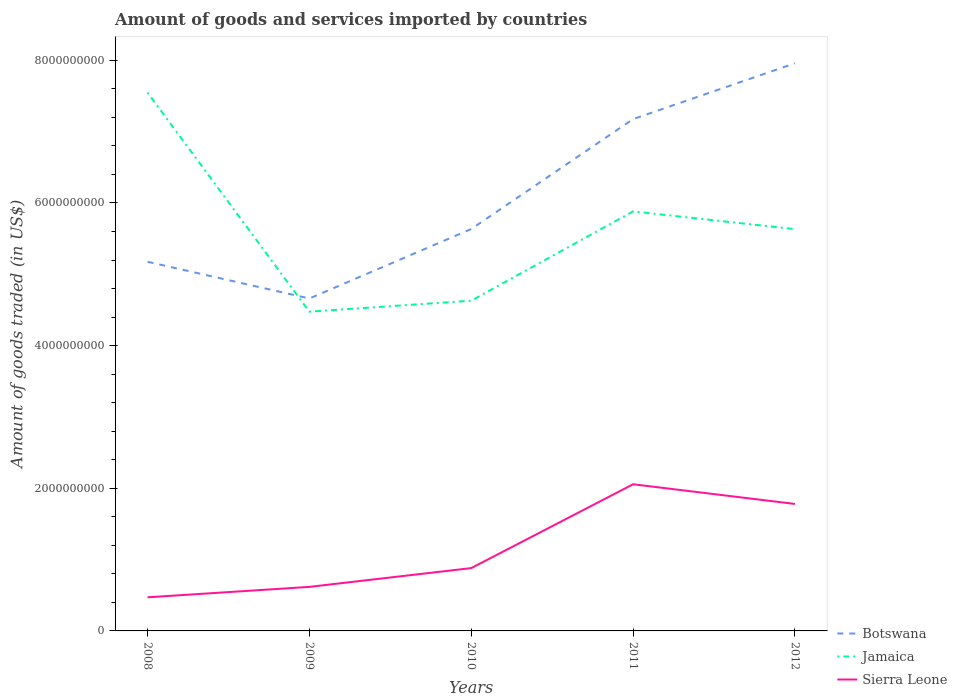How many different coloured lines are there?
Provide a short and direct response. 3. Is the number of lines equal to the number of legend labels?
Offer a terse response. Yes. Across all years, what is the maximum total amount of goods and services imported in Botswana?
Keep it short and to the point. 4.66e+09. What is the total total amount of goods and services imported in Jamaica in the graph?
Provide a succinct answer. -1.41e+09. What is the difference between the highest and the second highest total amount of goods and services imported in Jamaica?
Offer a very short reply. 3.07e+09. How many years are there in the graph?
Offer a very short reply. 5. What is the difference between two consecutive major ticks on the Y-axis?
Your answer should be compact. 2.00e+09. Are the values on the major ticks of Y-axis written in scientific E-notation?
Give a very brief answer. No. How are the legend labels stacked?
Offer a terse response. Vertical. What is the title of the graph?
Ensure brevity in your answer.  Amount of goods and services imported by countries. Does "Senegal" appear as one of the legend labels in the graph?
Provide a succinct answer. No. What is the label or title of the Y-axis?
Offer a very short reply. Amount of goods traded (in US$). What is the Amount of goods traded (in US$) in Botswana in 2008?
Ensure brevity in your answer.  5.18e+09. What is the Amount of goods traded (in US$) in Jamaica in 2008?
Provide a succinct answer. 7.55e+09. What is the Amount of goods traded (in US$) in Sierra Leone in 2008?
Provide a short and direct response. 4.71e+08. What is the Amount of goods traded (in US$) in Botswana in 2009?
Your response must be concise. 4.66e+09. What is the Amount of goods traded (in US$) in Jamaica in 2009?
Make the answer very short. 4.48e+09. What is the Amount of goods traded (in US$) in Sierra Leone in 2009?
Your answer should be compact. 6.18e+08. What is the Amount of goods traded (in US$) of Botswana in 2010?
Ensure brevity in your answer.  5.63e+09. What is the Amount of goods traded (in US$) in Jamaica in 2010?
Ensure brevity in your answer.  4.63e+09. What is the Amount of goods traded (in US$) of Sierra Leone in 2010?
Your answer should be compact. 8.81e+08. What is the Amount of goods traded (in US$) of Botswana in 2011?
Your response must be concise. 7.18e+09. What is the Amount of goods traded (in US$) of Jamaica in 2011?
Keep it short and to the point. 5.88e+09. What is the Amount of goods traded (in US$) of Sierra Leone in 2011?
Provide a succinct answer. 2.06e+09. What is the Amount of goods traded (in US$) in Botswana in 2012?
Offer a terse response. 7.96e+09. What is the Amount of goods traded (in US$) in Jamaica in 2012?
Offer a terse response. 5.63e+09. What is the Amount of goods traded (in US$) in Sierra Leone in 2012?
Keep it short and to the point. 1.78e+09. Across all years, what is the maximum Amount of goods traded (in US$) in Botswana?
Keep it short and to the point. 7.96e+09. Across all years, what is the maximum Amount of goods traded (in US$) of Jamaica?
Offer a very short reply. 7.55e+09. Across all years, what is the maximum Amount of goods traded (in US$) of Sierra Leone?
Your answer should be very brief. 2.06e+09. Across all years, what is the minimum Amount of goods traded (in US$) of Botswana?
Offer a very short reply. 4.66e+09. Across all years, what is the minimum Amount of goods traded (in US$) in Jamaica?
Ensure brevity in your answer.  4.48e+09. Across all years, what is the minimum Amount of goods traded (in US$) of Sierra Leone?
Provide a short and direct response. 4.71e+08. What is the total Amount of goods traded (in US$) in Botswana in the graph?
Your answer should be very brief. 3.06e+1. What is the total Amount of goods traded (in US$) of Jamaica in the graph?
Give a very brief answer. 2.82e+1. What is the total Amount of goods traded (in US$) of Sierra Leone in the graph?
Make the answer very short. 5.81e+09. What is the difference between the Amount of goods traded (in US$) in Botswana in 2008 and that in 2009?
Make the answer very short. 5.15e+08. What is the difference between the Amount of goods traded (in US$) in Jamaica in 2008 and that in 2009?
Your response must be concise. 3.07e+09. What is the difference between the Amount of goods traded (in US$) of Sierra Leone in 2008 and that in 2009?
Provide a short and direct response. -1.46e+08. What is the difference between the Amount of goods traded (in US$) of Botswana in 2008 and that in 2010?
Provide a short and direct response. -4.59e+08. What is the difference between the Amount of goods traded (in US$) of Jamaica in 2008 and that in 2010?
Keep it short and to the point. 2.92e+09. What is the difference between the Amount of goods traded (in US$) of Sierra Leone in 2008 and that in 2010?
Your answer should be very brief. -4.10e+08. What is the difference between the Amount of goods traded (in US$) in Botswana in 2008 and that in 2011?
Give a very brief answer. -2.00e+09. What is the difference between the Amount of goods traded (in US$) in Jamaica in 2008 and that in 2011?
Your response must be concise. 1.67e+09. What is the difference between the Amount of goods traded (in US$) in Sierra Leone in 2008 and that in 2011?
Your answer should be very brief. -1.58e+09. What is the difference between the Amount of goods traded (in US$) of Botswana in 2008 and that in 2012?
Offer a terse response. -2.78e+09. What is the difference between the Amount of goods traded (in US$) of Jamaica in 2008 and that in 2012?
Your answer should be very brief. 1.91e+09. What is the difference between the Amount of goods traded (in US$) of Sierra Leone in 2008 and that in 2012?
Make the answer very short. -1.31e+09. What is the difference between the Amount of goods traded (in US$) in Botswana in 2009 and that in 2010?
Ensure brevity in your answer.  -9.74e+08. What is the difference between the Amount of goods traded (in US$) of Jamaica in 2009 and that in 2010?
Provide a succinct answer. -1.54e+08. What is the difference between the Amount of goods traded (in US$) of Sierra Leone in 2009 and that in 2010?
Your answer should be very brief. -2.63e+08. What is the difference between the Amount of goods traded (in US$) of Botswana in 2009 and that in 2011?
Give a very brief answer. -2.52e+09. What is the difference between the Amount of goods traded (in US$) of Jamaica in 2009 and that in 2011?
Your answer should be very brief. -1.41e+09. What is the difference between the Amount of goods traded (in US$) in Sierra Leone in 2009 and that in 2011?
Your answer should be compact. -1.44e+09. What is the difference between the Amount of goods traded (in US$) of Botswana in 2009 and that in 2012?
Offer a very short reply. -3.30e+09. What is the difference between the Amount of goods traded (in US$) of Jamaica in 2009 and that in 2012?
Give a very brief answer. -1.16e+09. What is the difference between the Amount of goods traded (in US$) of Sierra Leone in 2009 and that in 2012?
Provide a succinct answer. -1.16e+09. What is the difference between the Amount of goods traded (in US$) of Botswana in 2010 and that in 2011?
Give a very brief answer. -1.54e+09. What is the difference between the Amount of goods traded (in US$) of Jamaica in 2010 and that in 2011?
Your answer should be compact. -1.25e+09. What is the difference between the Amount of goods traded (in US$) of Sierra Leone in 2010 and that in 2011?
Your answer should be compact. -1.18e+09. What is the difference between the Amount of goods traded (in US$) of Botswana in 2010 and that in 2012?
Keep it short and to the point. -2.32e+09. What is the difference between the Amount of goods traded (in US$) of Jamaica in 2010 and that in 2012?
Ensure brevity in your answer.  -1.00e+09. What is the difference between the Amount of goods traded (in US$) of Sierra Leone in 2010 and that in 2012?
Offer a terse response. -8.99e+08. What is the difference between the Amount of goods traded (in US$) of Botswana in 2011 and that in 2012?
Keep it short and to the point. -7.83e+08. What is the difference between the Amount of goods traded (in US$) of Jamaica in 2011 and that in 2012?
Provide a succinct answer. 2.49e+08. What is the difference between the Amount of goods traded (in US$) of Sierra Leone in 2011 and that in 2012?
Ensure brevity in your answer.  2.76e+08. What is the difference between the Amount of goods traded (in US$) in Botswana in 2008 and the Amount of goods traded (in US$) in Jamaica in 2009?
Make the answer very short. 7.00e+08. What is the difference between the Amount of goods traded (in US$) in Botswana in 2008 and the Amount of goods traded (in US$) in Sierra Leone in 2009?
Offer a very short reply. 4.56e+09. What is the difference between the Amount of goods traded (in US$) in Jamaica in 2008 and the Amount of goods traded (in US$) in Sierra Leone in 2009?
Offer a terse response. 6.93e+09. What is the difference between the Amount of goods traded (in US$) of Botswana in 2008 and the Amount of goods traded (in US$) of Jamaica in 2010?
Make the answer very short. 5.46e+08. What is the difference between the Amount of goods traded (in US$) in Botswana in 2008 and the Amount of goods traded (in US$) in Sierra Leone in 2010?
Offer a terse response. 4.29e+09. What is the difference between the Amount of goods traded (in US$) of Jamaica in 2008 and the Amount of goods traded (in US$) of Sierra Leone in 2010?
Provide a succinct answer. 6.67e+09. What is the difference between the Amount of goods traded (in US$) of Botswana in 2008 and the Amount of goods traded (in US$) of Jamaica in 2011?
Offer a terse response. -7.06e+08. What is the difference between the Amount of goods traded (in US$) of Botswana in 2008 and the Amount of goods traded (in US$) of Sierra Leone in 2011?
Ensure brevity in your answer.  3.12e+09. What is the difference between the Amount of goods traded (in US$) of Jamaica in 2008 and the Amount of goods traded (in US$) of Sierra Leone in 2011?
Give a very brief answer. 5.49e+09. What is the difference between the Amount of goods traded (in US$) of Botswana in 2008 and the Amount of goods traded (in US$) of Jamaica in 2012?
Your answer should be very brief. -4.57e+08. What is the difference between the Amount of goods traded (in US$) in Botswana in 2008 and the Amount of goods traded (in US$) in Sierra Leone in 2012?
Your answer should be compact. 3.40e+09. What is the difference between the Amount of goods traded (in US$) of Jamaica in 2008 and the Amount of goods traded (in US$) of Sierra Leone in 2012?
Keep it short and to the point. 5.77e+09. What is the difference between the Amount of goods traded (in US$) of Botswana in 2009 and the Amount of goods traded (in US$) of Jamaica in 2010?
Your response must be concise. 3.10e+07. What is the difference between the Amount of goods traded (in US$) in Botswana in 2009 and the Amount of goods traded (in US$) in Sierra Leone in 2010?
Provide a short and direct response. 3.78e+09. What is the difference between the Amount of goods traded (in US$) in Jamaica in 2009 and the Amount of goods traded (in US$) in Sierra Leone in 2010?
Provide a succinct answer. 3.59e+09. What is the difference between the Amount of goods traded (in US$) in Botswana in 2009 and the Amount of goods traded (in US$) in Jamaica in 2011?
Keep it short and to the point. -1.22e+09. What is the difference between the Amount of goods traded (in US$) in Botswana in 2009 and the Amount of goods traded (in US$) in Sierra Leone in 2011?
Give a very brief answer. 2.60e+09. What is the difference between the Amount of goods traded (in US$) of Jamaica in 2009 and the Amount of goods traded (in US$) of Sierra Leone in 2011?
Offer a terse response. 2.42e+09. What is the difference between the Amount of goods traded (in US$) of Botswana in 2009 and the Amount of goods traded (in US$) of Jamaica in 2012?
Your answer should be compact. -9.72e+08. What is the difference between the Amount of goods traded (in US$) of Botswana in 2009 and the Amount of goods traded (in US$) of Sierra Leone in 2012?
Your answer should be very brief. 2.88e+09. What is the difference between the Amount of goods traded (in US$) of Jamaica in 2009 and the Amount of goods traded (in US$) of Sierra Leone in 2012?
Offer a very short reply. 2.70e+09. What is the difference between the Amount of goods traded (in US$) of Botswana in 2010 and the Amount of goods traded (in US$) of Jamaica in 2011?
Offer a very short reply. -2.47e+08. What is the difference between the Amount of goods traded (in US$) in Botswana in 2010 and the Amount of goods traded (in US$) in Sierra Leone in 2011?
Give a very brief answer. 3.58e+09. What is the difference between the Amount of goods traded (in US$) of Jamaica in 2010 and the Amount of goods traded (in US$) of Sierra Leone in 2011?
Provide a short and direct response. 2.57e+09. What is the difference between the Amount of goods traded (in US$) in Botswana in 2010 and the Amount of goods traded (in US$) in Jamaica in 2012?
Ensure brevity in your answer.  1.99e+06. What is the difference between the Amount of goods traded (in US$) in Botswana in 2010 and the Amount of goods traded (in US$) in Sierra Leone in 2012?
Provide a succinct answer. 3.85e+09. What is the difference between the Amount of goods traded (in US$) of Jamaica in 2010 and the Amount of goods traded (in US$) of Sierra Leone in 2012?
Ensure brevity in your answer.  2.85e+09. What is the difference between the Amount of goods traded (in US$) in Botswana in 2011 and the Amount of goods traded (in US$) in Jamaica in 2012?
Your response must be concise. 1.54e+09. What is the difference between the Amount of goods traded (in US$) in Botswana in 2011 and the Amount of goods traded (in US$) in Sierra Leone in 2012?
Your answer should be compact. 5.40e+09. What is the difference between the Amount of goods traded (in US$) of Jamaica in 2011 and the Amount of goods traded (in US$) of Sierra Leone in 2012?
Keep it short and to the point. 4.10e+09. What is the average Amount of goods traded (in US$) of Botswana per year?
Offer a very short reply. 6.12e+09. What is the average Amount of goods traded (in US$) in Jamaica per year?
Provide a succinct answer. 5.63e+09. What is the average Amount of goods traded (in US$) in Sierra Leone per year?
Give a very brief answer. 1.16e+09. In the year 2008, what is the difference between the Amount of goods traded (in US$) in Botswana and Amount of goods traded (in US$) in Jamaica?
Ensure brevity in your answer.  -2.37e+09. In the year 2008, what is the difference between the Amount of goods traded (in US$) in Botswana and Amount of goods traded (in US$) in Sierra Leone?
Offer a very short reply. 4.70e+09. In the year 2008, what is the difference between the Amount of goods traded (in US$) of Jamaica and Amount of goods traded (in US$) of Sierra Leone?
Make the answer very short. 7.08e+09. In the year 2009, what is the difference between the Amount of goods traded (in US$) in Botswana and Amount of goods traded (in US$) in Jamaica?
Provide a short and direct response. 1.85e+08. In the year 2009, what is the difference between the Amount of goods traded (in US$) of Botswana and Amount of goods traded (in US$) of Sierra Leone?
Give a very brief answer. 4.04e+09. In the year 2009, what is the difference between the Amount of goods traded (in US$) in Jamaica and Amount of goods traded (in US$) in Sierra Leone?
Keep it short and to the point. 3.86e+09. In the year 2010, what is the difference between the Amount of goods traded (in US$) in Botswana and Amount of goods traded (in US$) in Jamaica?
Your answer should be compact. 1.00e+09. In the year 2010, what is the difference between the Amount of goods traded (in US$) in Botswana and Amount of goods traded (in US$) in Sierra Leone?
Ensure brevity in your answer.  4.75e+09. In the year 2010, what is the difference between the Amount of goods traded (in US$) of Jamaica and Amount of goods traded (in US$) of Sierra Leone?
Offer a very short reply. 3.75e+09. In the year 2011, what is the difference between the Amount of goods traded (in US$) in Botswana and Amount of goods traded (in US$) in Jamaica?
Ensure brevity in your answer.  1.29e+09. In the year 2011, what is the difference between the Amount of goods traded (in US$) in Botswana and Amount of goods traded (in US$) in Sierra Leone?
Offer a very short reply. 5.12e+09. In the year 2011, what is the difference between the Amount of goods traded (in US$) in Jamaica and Amount of goods traded (in US$) in Sierra Leone?
Give a very brief answer. 3.83e+09. In the year 2012, what is the difference between the Amount of goods traded (in US$) of Botswana and Amount of goods traded (in US$) of Jamaica?
Your answer should be compact. 2.33e+09. In the year 2012, what is the difference between the Amount of goods traded (in US$) in Botswana and Amount of goods traded (in US$) in Sierra Leone?
Your answer should be compact. 6.18e+09. In the year 2012, what is the difference between the Amount of goods traded (in US$) in Jamaica and Amount of goods traded (in US$) in Sierra Leone?
Ensure brevity in your answer.  3.85e+09. What is the ratio of the Amount of goods traded (in US$) of Botswana in 2008 to that in 2009?
Your response must be concise. 1.11. What is the ratio of the Amount of goods traded (in US$) of Jamaica in 2008 to that in 2009?
Your answer should be compact. 1.69. What is the ratio of the Amount of goods traded (in US$) in Sierra Leone in 2008 to that in 2009?
Your answer should be very brief. 0.76. What is the ratio of the Amount of goods traded (in US$) in Botswana in 2008 to that in 2010?
Your answer should be very brief. 0.92. What is the ratio of the Amount of goods traded (in US$) of Jamaica in 2008 to that in 2010?
Your answer should be compact. 1.63. What is the ratio of the Amount of goods traded (in US$) in Sierra Leone in 2008 to that in 2010?
Ensure brevity in your answer.  0.54. What is the ratio of the Amount of goods traded (in US$) of Botswana in 2008 to that in 2011?
Keep it short and to the point. 0.72. What is the ratio of the Amount of goods traded (in US$) of Jamaica in 2008 to that in 2011?
Offer a very short reply. 1.28. What is the ratio of the Amount of goods traded (in US$) in Sierra Leone in 2008 to that in 2011?
Keep it short and to the point. 0.23. What is the ratio of the Amount of goods traded (in US$) in Botswana in 2008 to that in 2012?
Make the answer very short. 0.65. What is the ratio of the Amount of goods traded (in US$) in Jamaica in 2008 to that in 2012?
Your answer should be very brief. 1.34. What is the ratio of the Amount of goods traded (in US$) of Sierra Leone in 2008 to that in 2012?
Make the answer very short. 0.26. What is the ratio of the Amount of goods traded (in US$) in Botswana in 2009 to that in 2010?
Provide a succinct answer. 0.83. What is the ratio of the Amount of goods traded (in US$) of Jamaica in 2009 to that in 2010?
Ensure brevity in your answer.  0.97. What is the ratio of the Amount of goods traded (in US$) of Sierra Leone in 2009 to that in 2010?
Your answer should be compact. 0.7. What is the ratio of the Amount of goods traded (in US$) of Botswana in 2009 to that in 2011?
Provide a succinct answer. 0.65. What is the ratio of the Amount of goods traded (in US$) in Jamaica in 2009 to that in 2011?
Provide a short and direct response. 0.76. What is the ratio of the Amount of goods traded (in US$) of Sierra Leone in 2009 to that in 2011?
Keep it short and to the point. 0.3. What is the ratio of the Amount of goods traded (in US$) of Botswana in 2009 to that in 2012?
Your response must be concise. 0.59. What is the ratio of the Amount of goods traded (in US$) in Jamaica in 2009 to that in 2012?
Give a very brief answer. 0.79. What is the ratio of the Amount of goods traded (in US$) in Sierra Leone in 2009 to that in 2012?
Provide a succinct answer. 0.35. What is the ratio of the Amount of goods traded (in US$) of Botswana in 2010 to that in 2011?
Make the answer very short. 0.79. What is the ratio of the Amount of goods traded (in US$) of Jamaica in 2010 to that in 2011?
Your answer should be very brief. 0.79. What is the ratio of the Amount of goods traded (in US$) in Sierra Leone in 2010 to that in 2011?
Ensure brevity in your answer.  0.43. What is the ratio of the Amount of goods traded (in US$) of Botswana in 2010 to that in 2012?
Offer a very short reply. 0.71. What is the ratio of the Amount of goods traded (in US$) of Jamaica in 2010 to that in 2012?
Your answer should be very brief. 0.82. What is the ratio of the Amount of goods traded (in US$) of Sierra Leone in 2010 to that in 2012?
Offer a terse response. 0.49. What is the ratio of the Amount of goods traded (in US$) of Botswana in 2011 to that in 2012?
Your response must be concise. 0.9. What is the ratio of the Amount of goods traded (in US$) of Jamaica in 2011 to that in 2012?
Your response must be concise. 1.04. What is the ratio of the Amount of goods traded (in US$) in Sierra Leone in 2011 to that in 2012?
Offer a terse response. 1.16. What is the difference between the highest and the second highest Amount of goods traded (in US$) in Botswana?
Keep it short and to the point. 7.83e+08. What is the difference between the highest and the second highest Amount of goods traded (in US$) of Jamaica?
Offer a very short reply. 1.67e+09. What is the difference between the highest and the second highest Amount of goods traded (in US$) in Sierra Leone?
Your answer should be very brief. 2.76e+08. What is the difference between the highest and the lowest Amount of goods traded (in US$) of Botswana?
Give a very brief answer. 3.30e+09. What is the difference between the highest and the lowest Amount of goods traded (in US$) in Jamaica?
Your response must be concise. 3.07e+09. What is the difference between the highest and the lowest Amount of goods traded (in US$) of Sierra Leone?
Keep it short and to the point. 1.58e+09. 